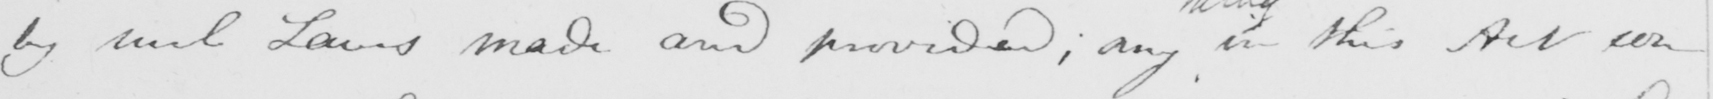What does this handwritten line say? by such Laws made and provided ; any in this Act con- 